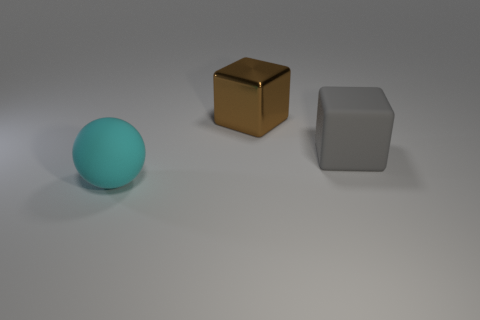Is there any other thing that has the same material as the brown block?
Offer a very short reply. No. Are there any other big cyan things that have the same shape as the cyan thing?
Offer a very short reply. No. There is a sphere that is the same size as the metal object; what is its color?
Keep it short and to the point. Cyan. What is the size of the object behind the gray cube?
Ensure brevity in your answer.  Large. There is a big object that is in front of the rubber block; is there a rubber thing in front of it?
Give a very brief answer. No. Is the cyan ball that is on the left side of the metal thing made of the same material as the large gray block?
Your answer should be compact. Yes. How many objects are behind the big rubber sphere and in front of the brown metallic object?
Provide a short and direct response. 1. What number of large blocks have the same material as the cyan sphere?
Keep it short and to the point. 1. What color is the other large thing that is the same material as the gray thing?
Ensure brevity in your answer.  Cyan. Is the number of brown blocks less than the number of things?
Provide a short and direct response. Yes. 